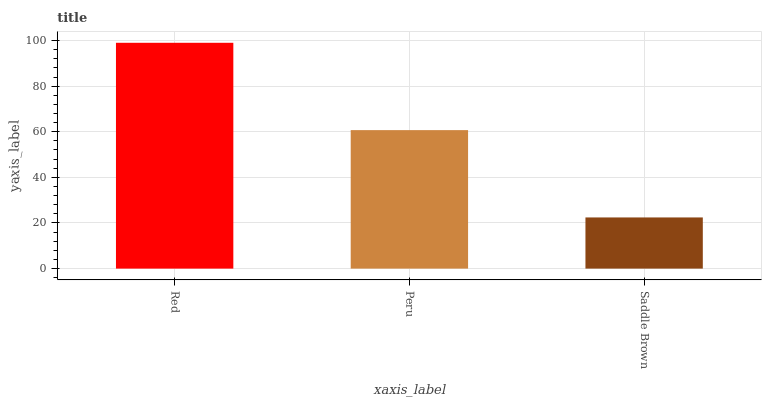Is Peru the minimum?
Answer yes or no. No. Is Peru the maximum?
Answer yes or no. No. Is Red greater than Peru?
Answer yes or no. Yes. Is Peru less than Red?
Answer yes or no. Yes. Is Peru greater than Red?
Answer yes or no. No. Is Red less than Peru?
Answer yes or no. No. Is Peru the high median?
Answer yes or no. Yes. Is Peru the low median?
Answer yes or no. Yes. Is Red the high median?
Answer yes or no. No. Is Saddle Brown the low median?
Answer yes or no. No. 